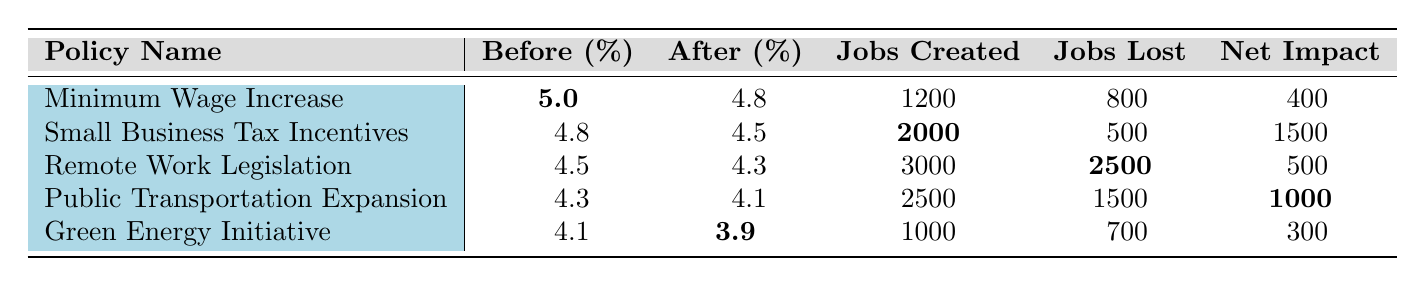What was the employment rate before the Minimum Wage Increase policy? The table indicates that the employment rate before the Minimum Wage Increase policy was **5.0%**.
Answer: 5.0% How many jobs were created by the Small Business Tax Incentives? According to the table, the Small Business Tax Incentives led to the creation of **2000 jobs**.
Answer: 2000 What was the net impact of the Remote Work Legislation? The net impact of the Remote Work Legislation is recorded as **500** jobs.
Answer: 500 Did the employment rate decrease after the Public Transportation Expansion? The employment rate after this policy was **4.1%**, down from **4.3%**, indicating a decrease.
Answer: Yes What was the total number of jobs created across all policies? Summing the jobs created gives: 1200 (Minimum Wage Increase) + 2000 (Small Business Tax Incentives) + 3000 (Remote Work Legislation) + 2500 (Public Transportation Expansion) + 1000 (Green Energy Initiative) = 9700 jobs created in total.
Answer: 9700 Which policy had the highest number of jobs lost? The table shows that the policy with the most jobs lost is the Remote Work Legislation, with **2500 jobs lost**.
Answer: 2500 What is the average employment rate before the policies were implemented? The average before rates are calculated as (5.0 + 4.8 + 4.5 + 4.3 + 4.1) / 5 = 4.54%.
Answer: 4.54% Identify one policy that resulted in a positive net impact. The Small Business Tax Incentives resulted in a net impact of **1500 jobs**, which is positive.
Answer: Yes How did the employment rate change from before to after the Green Energy Initiative? The employment rate changed from **4.1%** before to **3.9%** after, showing a decrease of **0.2%**.
Answer: Decreased What is the difference between jobs created and jobs lost for the Public Transportation Expansion? The difference is calculated as jobs created (2500) minus jobs lost (1500), leading to a net positive impact of **1000** jobs.
Answer: 1000 